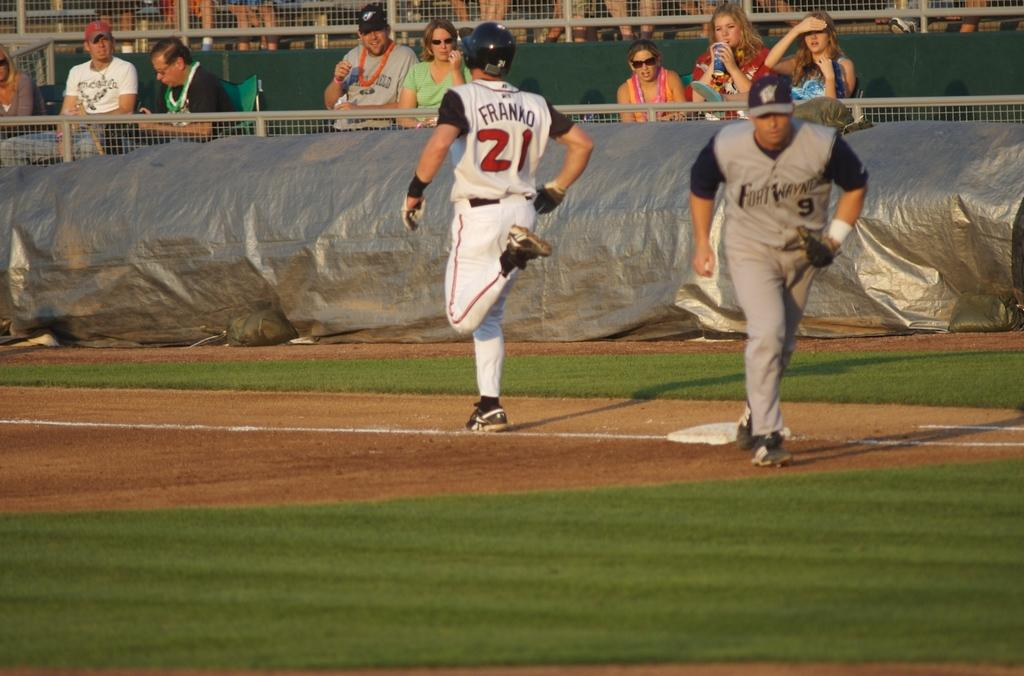<image>
Summarize the visual content of the image. During a baseball game, Franko runs past first base while first baseman from Fort Wayne moves towards the dugout. 